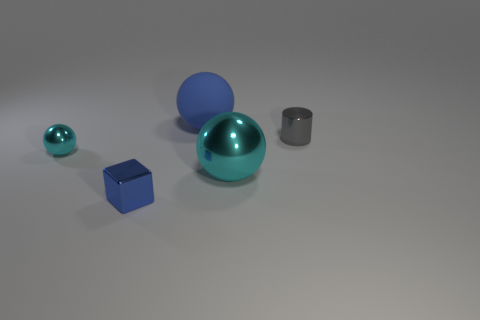Add 2 tiny gray shiny cylinders. How many objects exist? 7 Subtract all cylinders. How many objects are left? 4 Subtract 0 cyan cylinders. How many objects are left? 5 Subtract all large cyan shiny spheres. Subtract all big blue spheres. How many objects are left? 3 Add 3 big blue rubber objects. How many big blue rubber objects are left? 4 Add 5 blue things. How many blue things exist? 7 